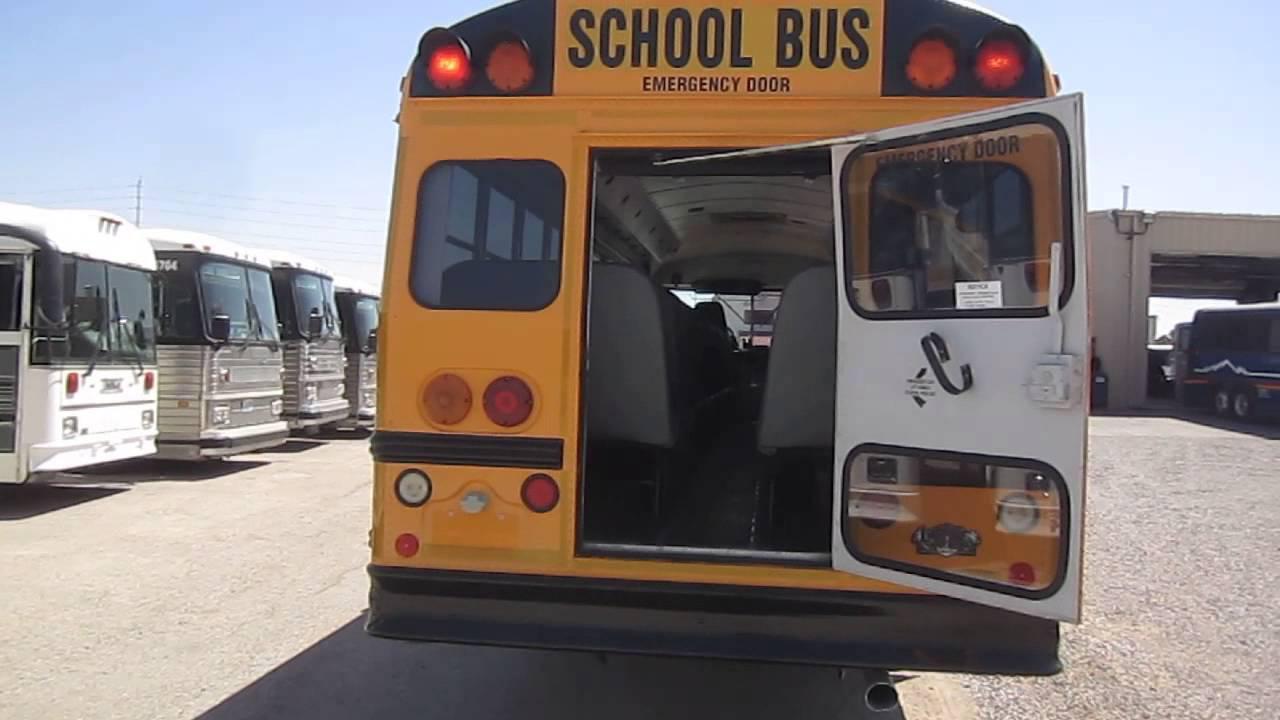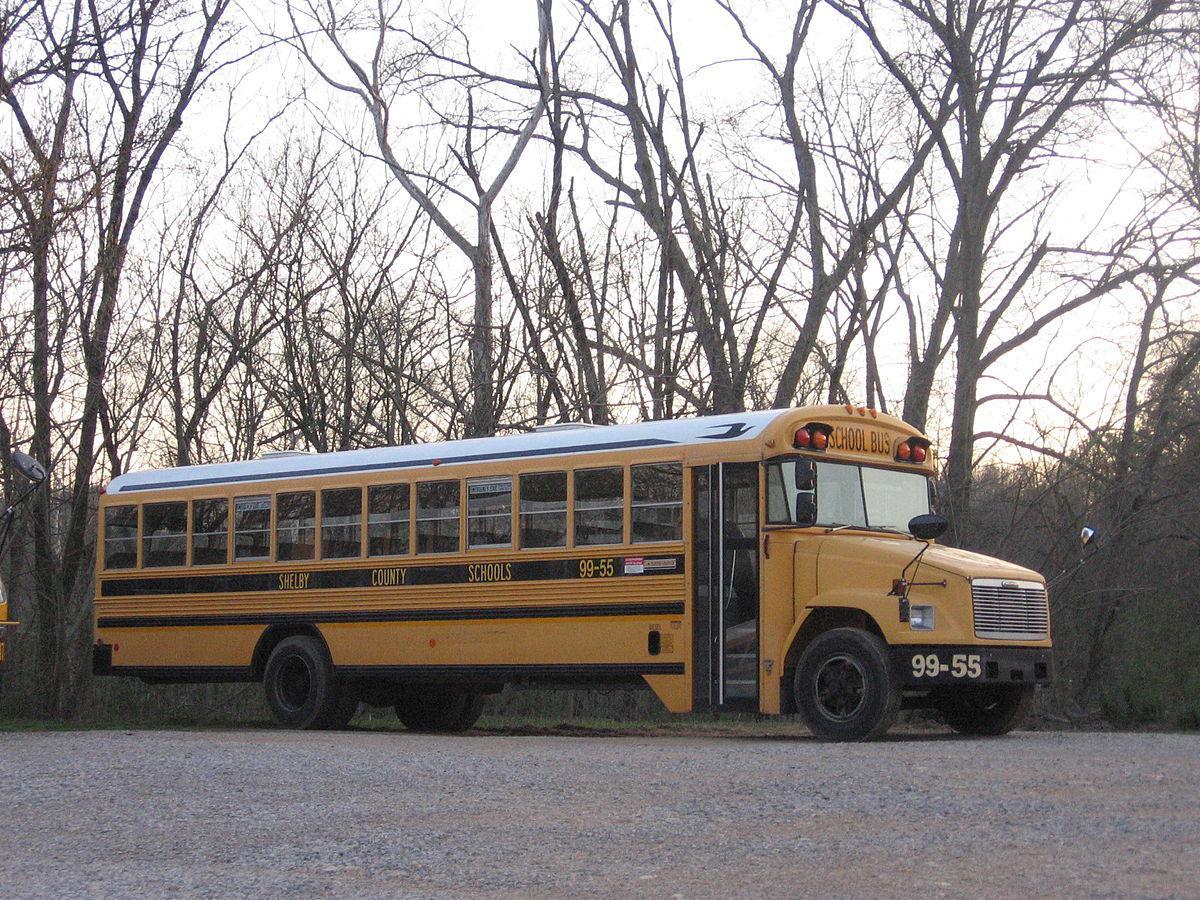The first image is the image on the left, the second image is the image on the right. For the images displayed, is the sentence "All the school buses in the images are facing to the left." factually correct? Answer yes or no. No. The first image is the image on the left, the second image is the image on the right. Considering the images on both sides, is "One of the images features two school buses beside each other." valid? Answer yes or no. No. 